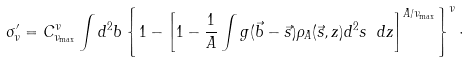Convert formula to latex. <formula><loc_0><loc_0><loc_500><loc_500>\sigma _ { \nu } ^ { \prime } = C ^ { \nu } _ { \nu _ { \max } } \int d ^ { 2 } b \left \{ 1 - \left [ 1 - \frac { 1 } { A } \int g ( \vec { b } - \vec { s } ) \rho _ { A } ( \vec { s } , z ) d ^ { 2 } s \ d z \right ] ^ { A / \nu _ { \max } } \right \} ^ { \nu } \cdot</formula> 